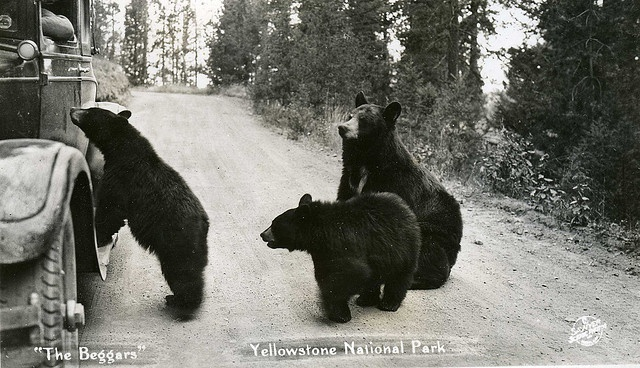Describe the objects in this image and their specific colors. I can see truck in black, gray, darkgray, and lightgray tones, bear in black, gray, and darkgray tones, bear in black, gray, and darkgray tones, bear in black, gray, and darkgray tones, and people in black, gray, darkgray, and lightgray tones in this image. 